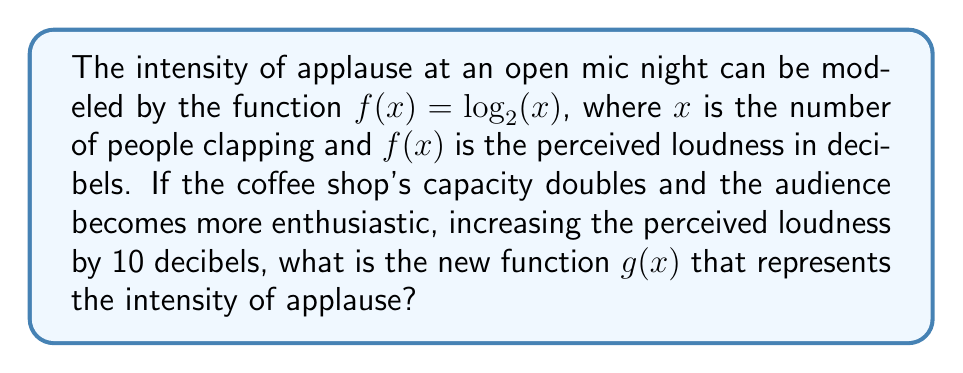Show me your answer to this math problem. To solve this problem, we need to apply both a horizontal and vertical transformation to the original function $f(x) = \log_2(x)$.

Step 1: Account for the doubled capacity
The coffee shop's capacity doubling means we need to compress the function horizontally by a factor of 2. This is done by replacing $x$ with $2x$ in the original function:

$f(2x) = \log_2(2x)$

Step 2: Account for the increased enthusiasm
The perceived loudness increasing by 10 decibels means we need to shift the function vertically by 10 units. This is done by adding 10 to the function:

$\log_2(2x) + 10$

Step 3: Combine the transformations
The new function $g(x)$ that represents the intensity of applause after both transformations is:

$g(x) = \log_2(2x) + 10$

Step 4: Simplify using logarithm properties
We can simplify this further using the logarithm property $\log_a(bc) = \log_a(b) + \log_a(c)$:

$g(x) = \log_2(2) + \log_2(x) + 10$

Since $\log_2(2) = 1$, we can simplify to:

$g(x) = \log_2(x) + 11$

This final form represents the new function for the intensity of applause, incorporating both the doubled capacity and increased enthusiasm.
Answer: $g(x) = \log_2(x) + 11$ 